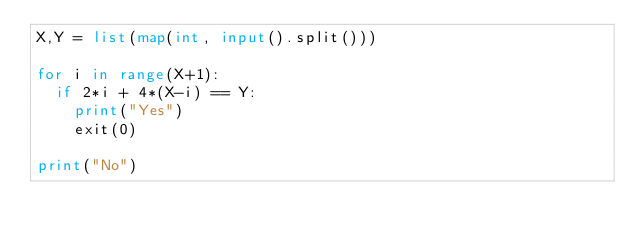<code> <loc_0><loc_0><loc_500><loc_500><_Python_>X,Y = list(map(int, input().split()))

for i in range(X+1):
  if 2*i + 4*(X-i) == Y:
    print("Yes")
    exit(0)
    
print("No")</code> 